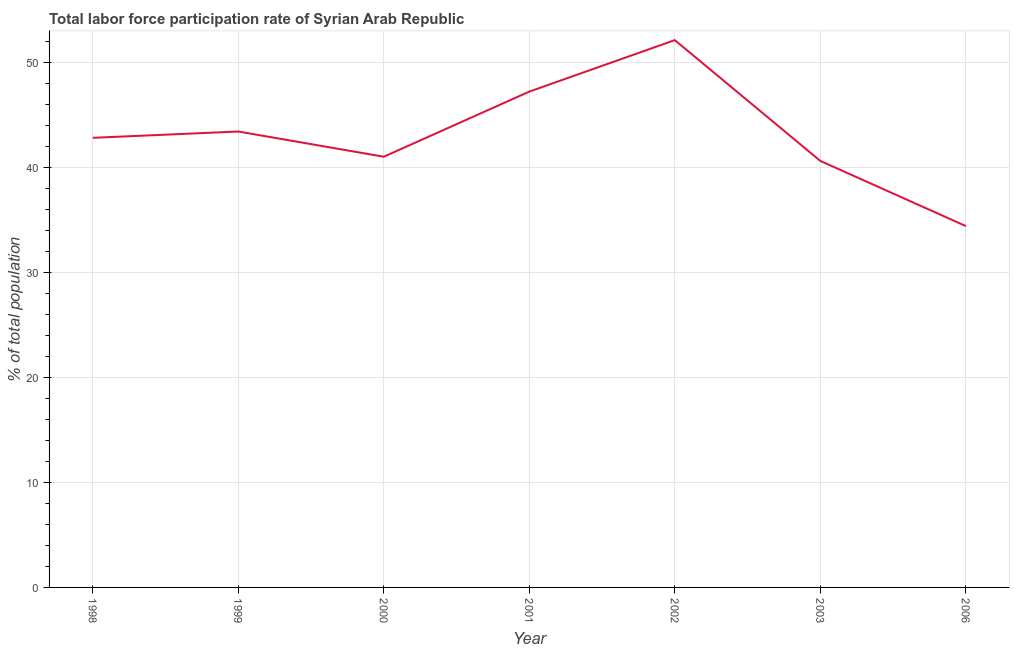What is the total labor force participation rate in 2001?
Make the answer very short. 47.2. Across all years, what is the maximum total labor force participation rate?
Ensure brevity in your answer.  52.1. Across all years, what is the minimum total labor force participation rate?
Offer a terse response. 34.4. In which year was the total labor force participation rate maximum?
Provide a short and direct response. 2002. In which year was the total labor force participation rate minimum?
Provide a succinct answer. 2006. What is the sum of the total labor force participation rate?
Keep it short and to the point. 301.5. What is the difference between the total labor force participation rate in 1998 and 2000?
Provide a succinct answer. 1.8. What is the average total labor force participation rate per year?
Ensure brevity in your answer.  43.07. What is the median total labor force participation rate?
Make the answer very short. 42.8. Do a majority of the years between 2001 and 2000 (inclusive) have total labor force participation rate greater than 6 %?
Provide a short and direct response. No. What is the ratio of the total labor force participation rate in 1998 to that in 2001?
Offer a very short reply. 0.91. Is the total labor force participation rate in 2000 less than that in 2002?
Make the answer very short. Yes. Is the difference between the total labor force participation rate in 1999 and 2002 greater than the difference between any two years?
Provide a succinct answer. No. What is the difference between the highest and the second highest total labor force participation rate?
Offer a very short reply. 4.9. Is the sum of the total labor force participation rate in 2001 and 2002 greater than the maximum total labor force participation rate across all years?
Make the answer very short. Yes. What is the difference between the highest and the lowest total labor force participation rate?
Your response must be concise. 17.7. How many lines are there?
Your answer should be compact. 1. How many years are there in the graph?
Your answer should be very brief. 7. Are the values on the major ticks of Y-axis written in scientific E-notation?
Offer a terse response. No. Does the graph contain grids?
Give a very brief answer. Yes. What is the title of the graph?
Offer a very short reply. Total labor force participation rate of Syrian Arab Republic. What is the label or title of the X-axis?
Provide a succinct answer. Year. What is the label or title of the Y-axis?
Your answer should be very brief. % of total population. What is the % of total population of 1998?
Keep it short and to the point. 42.8. What is the % of total population in 1999?
Give a very brief answer. 43.4. What is the % of total population in 2001?
Make the answer very short. 47.2. What is the % of total population in 2002?
Offer a terse response. 52.1. What is the % of total population in 2003?
Give a very brief answer. 40.6. What is the % of total population in 2006?
Give a very brief answer. 34.4. What is the difference between the % of total population in 1998 and 1999?
Offer a very short reply. -0.6. What is the difference between the % of total population in 1998 and 2000?
Your answer should be very brief. 1.8. What is the difference between the % of total population in 1998 and 2002?
Give a very brief answer. -9.3. What is the difference between the % of total population in 1998 and 2006?
Give a very brief answer. 8.4. What is the difference between the % of total population in 1999 and 2002?
Provide a succinct answer. -8.7. What is the difference between the % of total population in 2000 and 2002?
Your answer should be compact. -11.1. What is the difference between the % of total population in 2000 and 2003?
Give a very brief answer. 0.4. What is the difference between the % of total population in 2000 and 2006?
Your response must be concise. 6.6. What is the difference between the % of total population in 2002 and 2003?
Offer a terse response. 11.5. What is the difference between the % of total population in 2003 and 2006?
Your answer should be very brief. 6.2. What is the ratio of the % of total population in 1998 to that in 2000?
Ensure brevity in your answer.  1.04. What is the ratio of the % of total population in 1998 to that in 2001?
Your response must be concise. 0.91. What is the ratio of the % of total population in 1998 to that in 2002?
Make the answer very short. 0.82. What is the ratio of the % of total population in 1998 to that in 2003?
Your response must be concise. 1.05. What is the ratio of the % of total population in 1998 to that in 2006?
Make the answer very short. 1.24. What is the ratio of the % of total population in 1999 to that in 2000?
Provide a short and direct response. 1.06. What is the ratio of the % of total population in 1999 to that in 2001?
Provide a succinct answer. 0.92. What is the ratio of the % of total population in 1999 to that in 2002?
Your answer should be compact. 0.83. What is the ratio of the % of total population in 1999 to that in 2003?
Provide a short and direct response. 1.07. What is the ratio of the % of total population in 1999 to that in 2006?
Provide a succinct answer. 1.26. What is the ratio of the % of total population in 2000 to that in 2001?
Offer a terse response. 0.87. What is the ratio of the % of total population in 2000 to that in 2002?
Provide a succinct answer. 0.79. What is the ratio of the % of total population in 2000 to that in 2006?
Give a very brief answer. 1.19. What is the ratio of the % of total population in 2001 to that in 2002?
Provide a short and direct response. 0.91. What is the ratio of the % of total population in 2001 to that in 2003?
Your answer should be compact. 1.16. What is the ratio of the % of total population in 2001 to that in 2006?
Your response must be concise. 1.37. What is the ratio of the % of total population in 2002 to that in 2003?
Your answer should be very brief. 1.28. What is the ratio of the % of total population in 2002 to that in 2006?
Provide a succinct answer. 1.51. What is the ratio of the % of total population in 2003 to that in 2006?
Provide a short and direct response. 1.18. 